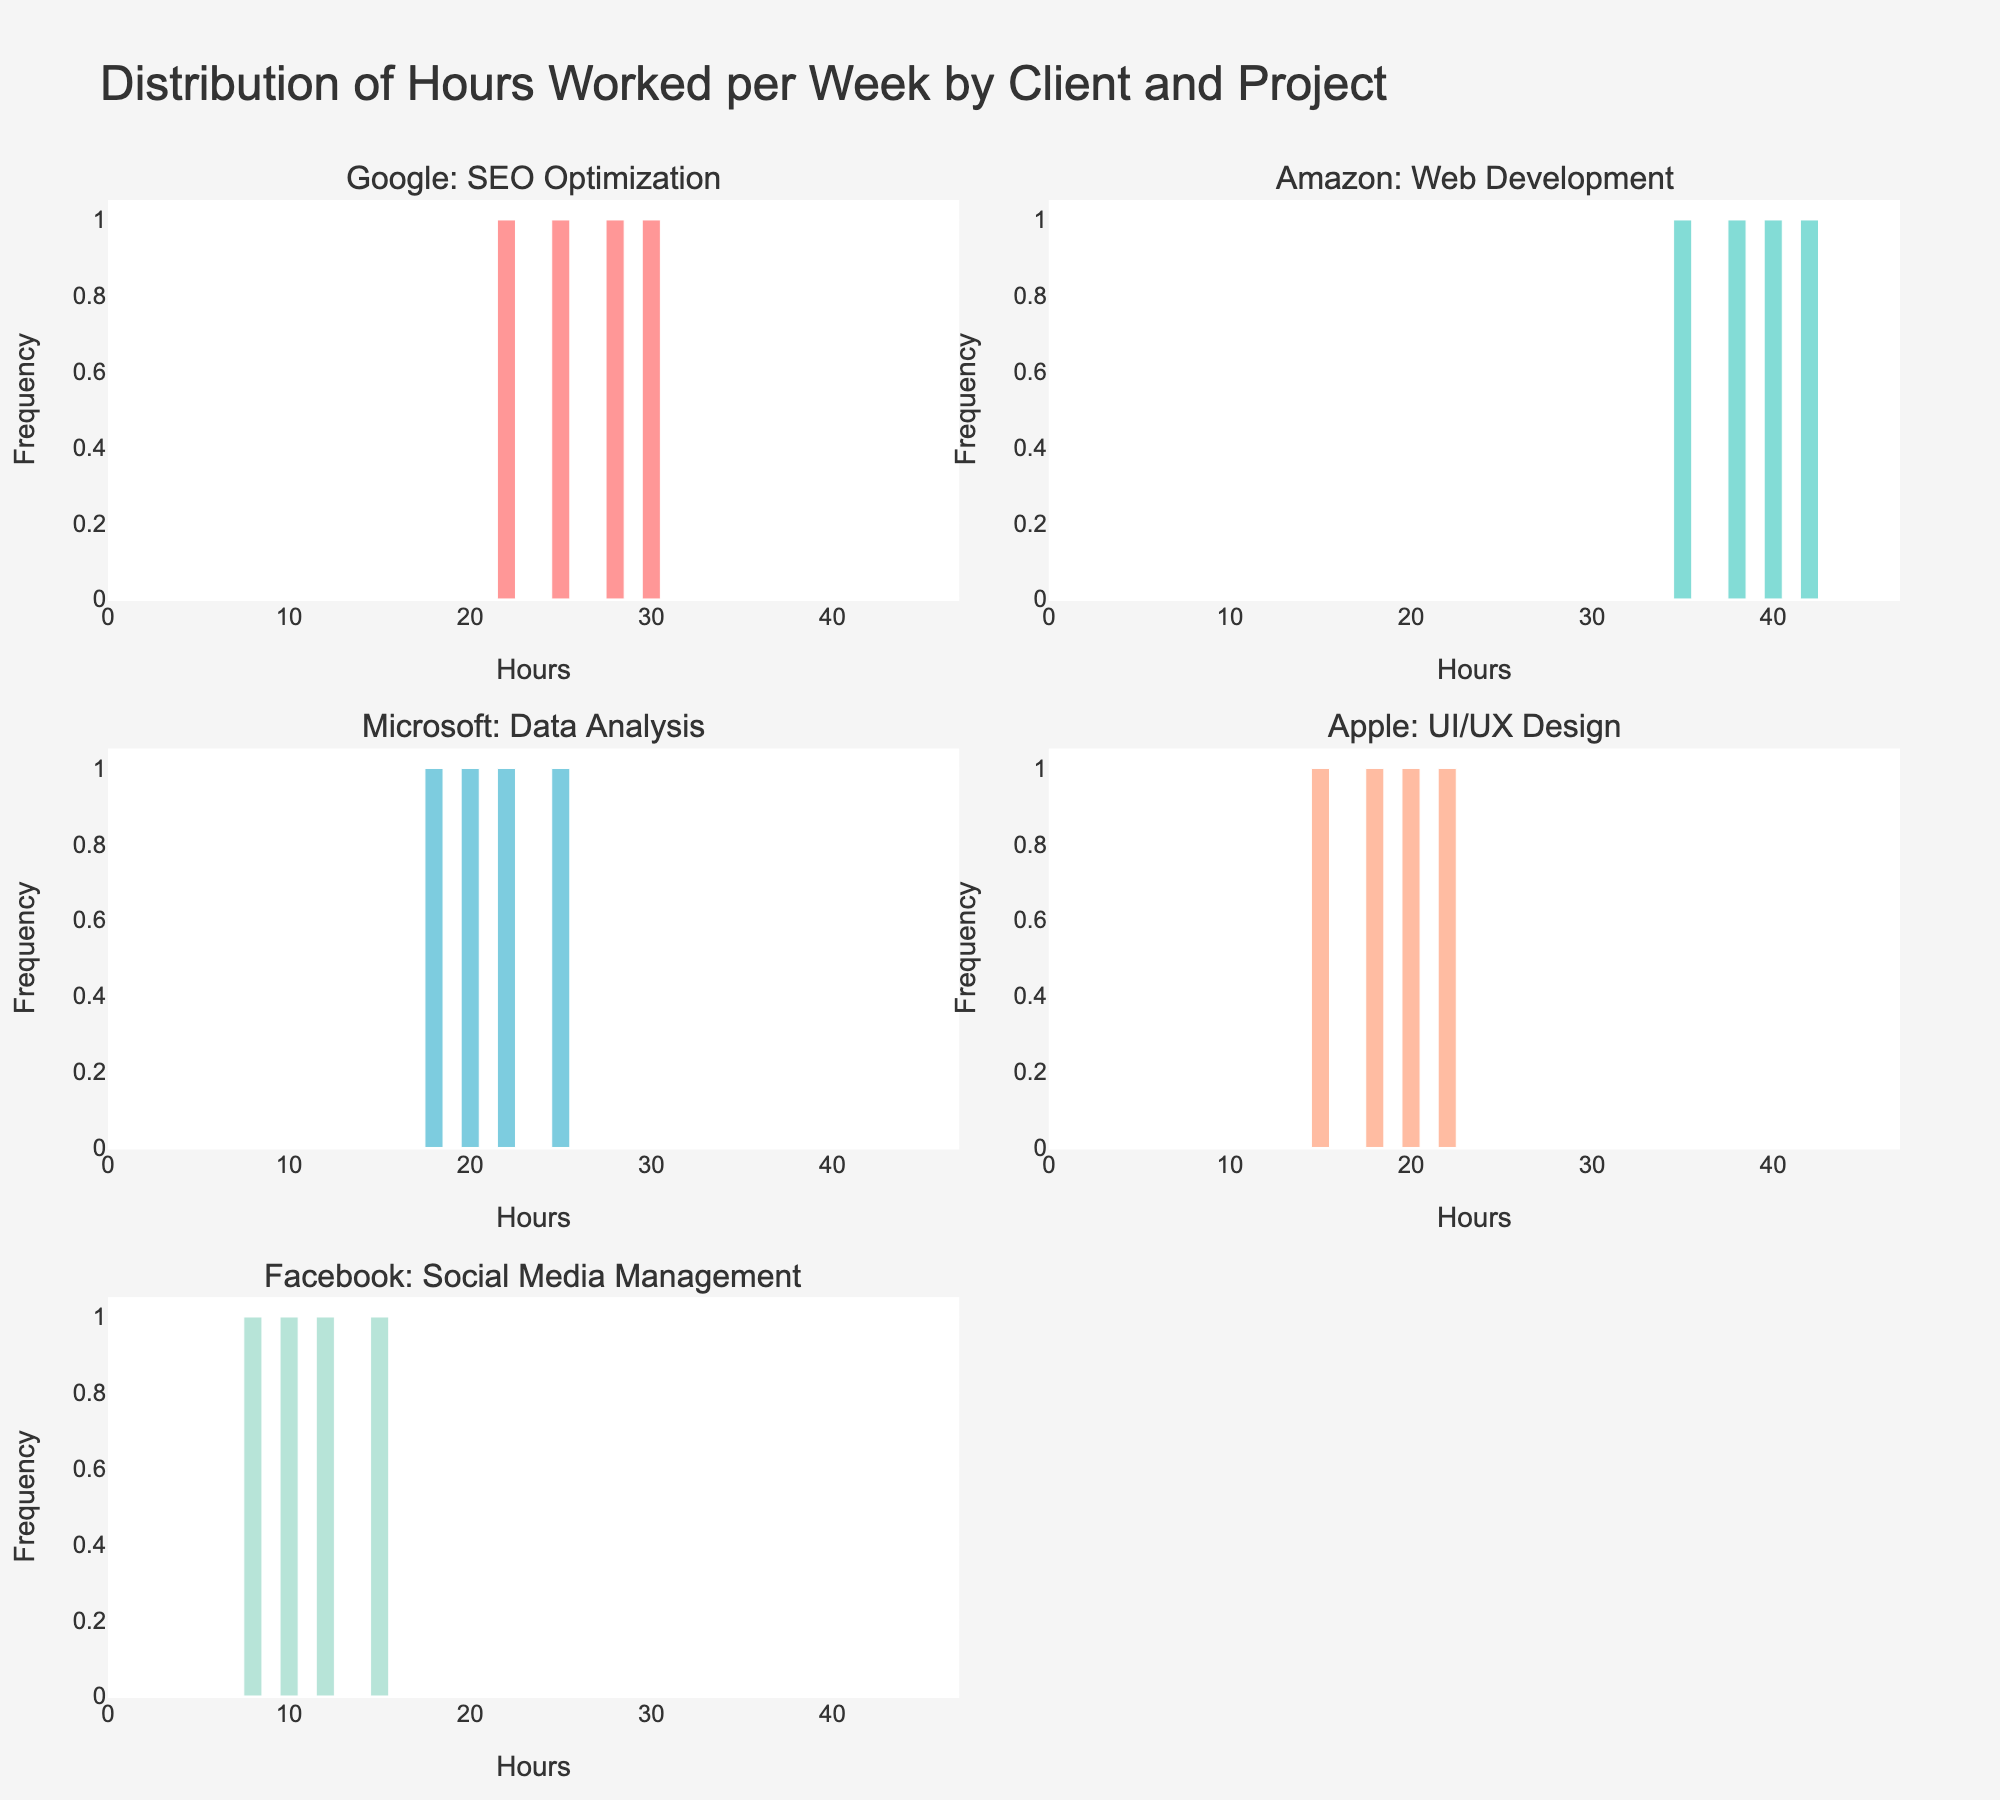what is the title of the overall plot figure? The title is located at the top of the plot. It states, "Distribution of Hours Worked per Week by Client and Project". This title indicates what the figure is displaying.
Answer: Distribution of Hours Worked per Week by Client and Project What is the horizontal axis label in the subplots? The horizontal axis label is present in each subplot. They all state "Hours", which indicates the number of hours worked.
Answer: Hours Which project has the highest frequency of hours worked? The subplots display histograms where the height of the bars indicates the frequency of hours worked. Compare the tallest bars across all subplots to see which project has the highest frequency.
Answer: Amazon: Web Development Across which client is the workload most variable? To find the most variable workload, observe the spread of hours worked in each subplot. The project with the tallest bars spread over a wider range of hours shows the most variability.
Answer: Facebook: Social Media Management How does the workload for UI/UX Design (Apple) compare to SEO Optimization (Google)? Compare the histograms for both projects in terms of the distribution of hours worked. The spread and height of bars in the Apple subplot versus Google will give the answer.
Answer: Google: SEO Optimization has more hours worked on average What is the maximum number of hours worked in the Web Development (Amazon) project? Look at the histogram for Amazon: Web Development and identify the rightmost bar. The maximum value in its range represents the maximum number of hours worked.
Answer: 42 What is the most common number of hours worked in Data Analysis (Microsoft)? In the Microsoft: Data Analysis subplot, find the tallest bar. The x-value at the peak of this bar indicates the most common number of hours worked per week.
Answer: 20 Which project has the smallest range of hours worked? Determine the range by looking at the spread (width) of the histogram bars for each project's subplot. The smallest spread indicates the smallest range.
Answer: Apple: UI/UX Design Is there a client whose project hours almost never exceed 30 hours per week? By analyzing each subplot, check if the bars extend beyond the 30-hour mark. The client with all bars under or just around 30 hours fits this description.
Answer: Google: SEO Optimization What is the difference between the maximum and minimum hours worked on Social Media Management (Facebook)? Identify the rightmost and leftmost parts in Facebook: Social Media Management histogram. The difference between these values gives the desired range. The leftmost is 8, and the rightmost is 15, thus, 15 - 8.
Answer: 7 